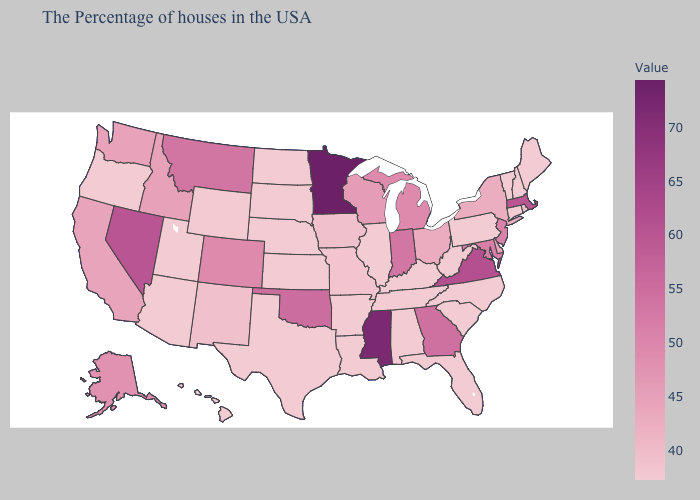Does Tennessee have the lowest value in the USA?
Short answer required. Yes. Is the legend a continuous bar?
Concise answer only. Yes. Does Maryland have the lowest value in the South?
Quick response, please. No. Does Oklahoma have the highest value in the South?
Be succinct. No. Among the states that border Michigan , does Wisconsin have the highest value?
Answer briefly. No. Among the states that border Connecticut , which have the highest value?
Short answer required. Massachusetts. 